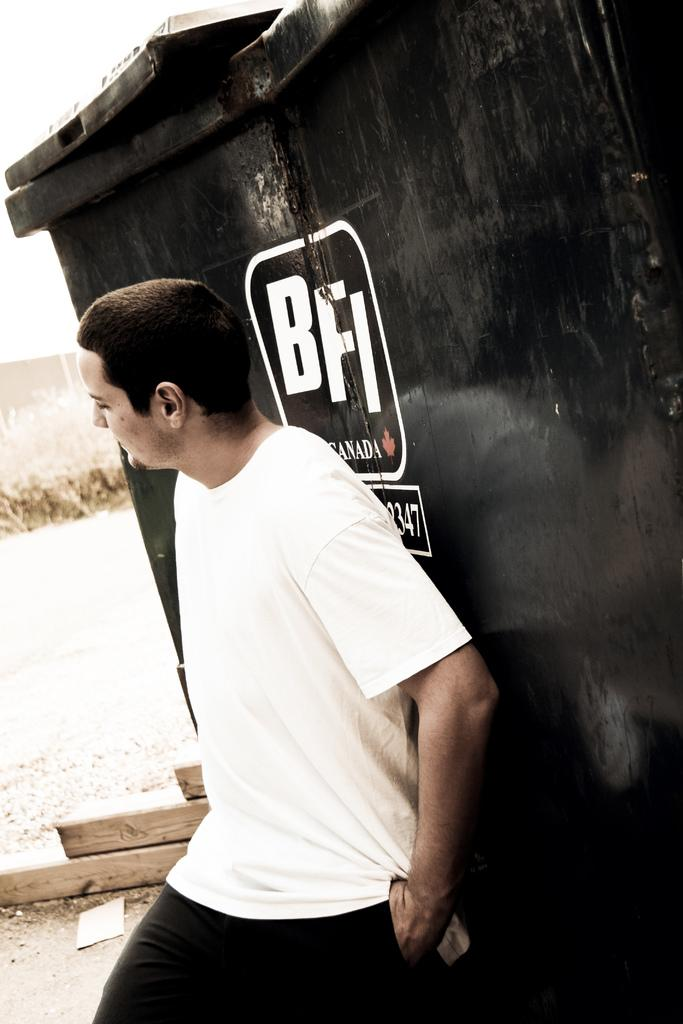What is the main subject of the image? There is a man standing in the image. What is behind the man in the image? There is a black object with text behind the man. What can be seen in the background of the image? The ground and grass are visible in the background of the image. What type of crib is visible in the image? There is no crib present in the image. How many cars can be seen in the image? There are no cars visible in the image. 